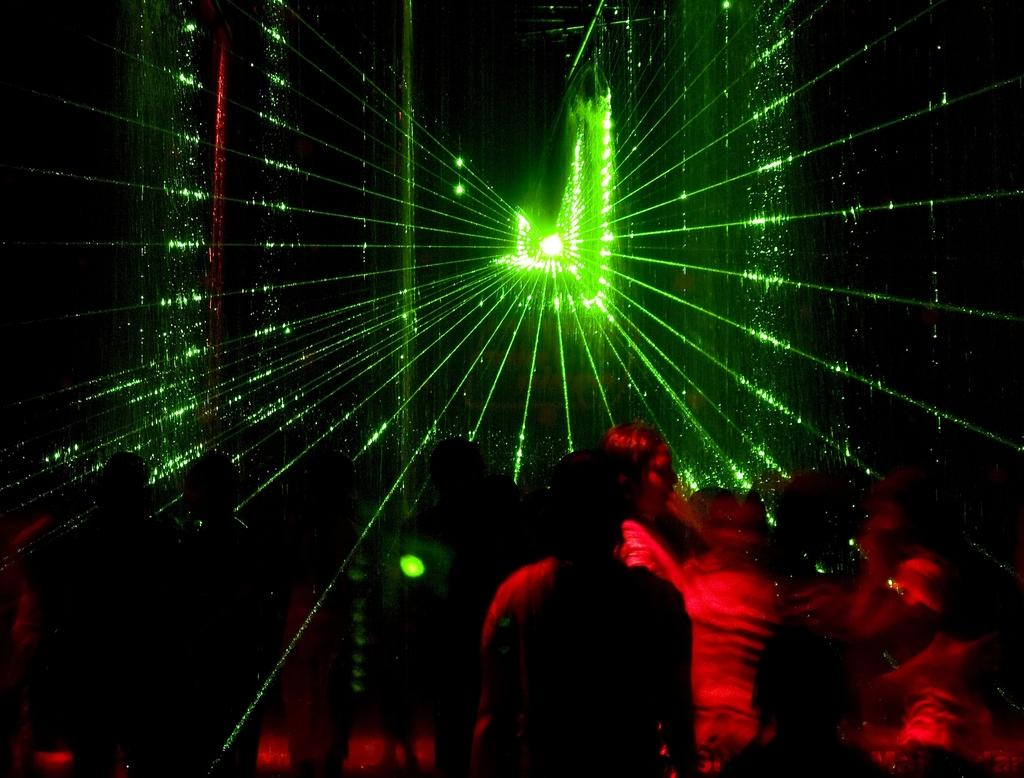What is happening with the people in the image? The people are present on the floor in the image. Can you describe the lighting in the image? There is a light source visible above the people, and the light is scattered in multiple directions. What type of receipt can be seen in the hands of the people in the image? There is no receipt present in the image; the people are simply on the floor. 